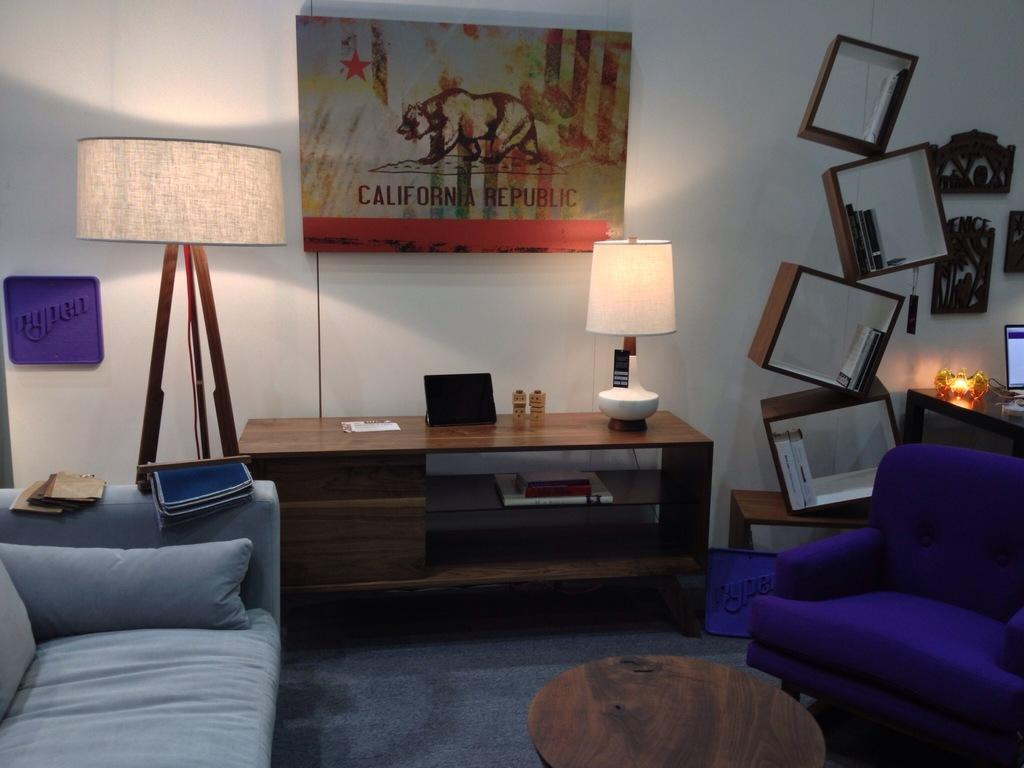What type of furniture is present in the room? There is a sofa with pillows in the room. What is on the table in the room? There are there any light sources? What can be seen on the walls? There are frames and books on the wall, as well as a light and a screen. What type of hydrant is present in the room? There is no hydrant present in the room; the image only shows a sofa, tables, lamp, tab, frames, books, light, and screen. 